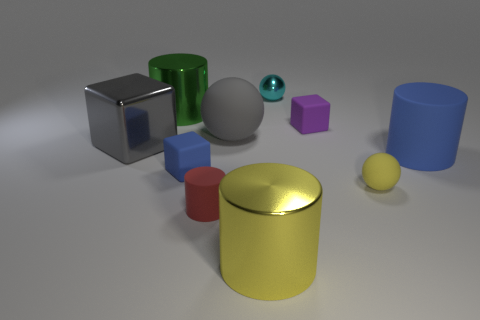How many balls are either gray things or large blue matte things?
Provide a short and direct response. 1. Does the small sphere in front of the large gray shiny thing have the same color as the big ball?
Offer a terse response. No. What material is the sphere that is on the left side of the shiny cylinder in front of the rubber object that is to the right of the tiny yellow ball made of?
Keep it short and to the point. Rubber. Is the size of the blue rubber cylinder the same as the cyan metal sphere?
Provide a short and direct response. No. There is a big sphere; does it have the same color as the matte cylinder that is in front of the small yellow matte thing?
Your answer should be compact. No. What shape is the large green object that is the same material as the cyan object?
Your response must be concise. Cylinder. Does the large yellow metallic thing that is to the right of the big gray cube have the same shape as the small metallic object?
Your answer should be very brief. No. What size is the blue thing that is left of the rubber cylinder that is right of the purple thing?
Your answer should be very brief. Small. What color is the small sphere that is made of the same material as the big yellow cylinder?
Provide a short and direct response. Cyan. How many metal spheres have the same size as the yellow matte sphere?
Give a very brief answer. 1. 